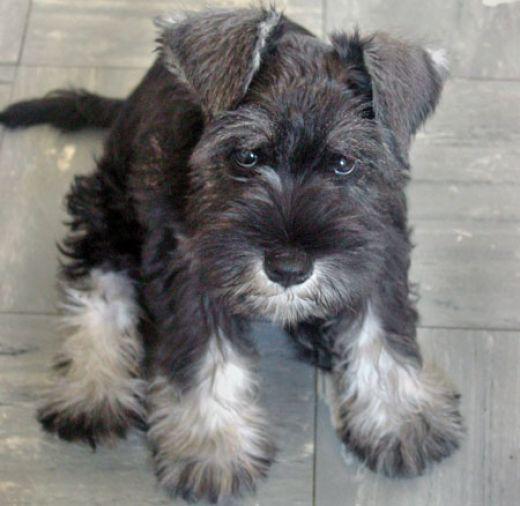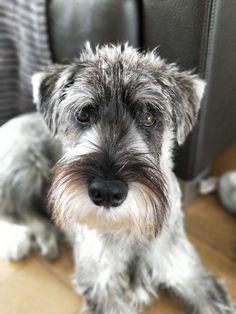The first image is the image on the left, the second image is the image on the right. For the images displayed, is the sentence "Some of the dogs are inside and the others are outside in the grass." factually correct? Answer yes or no. No. The first image is the image on the left, the second image is the image on the right. Considering the images on both sides, is "In one image, there are two Miniature Schnauzers sitting on some furniture." valid? Answer yes or no. No. 